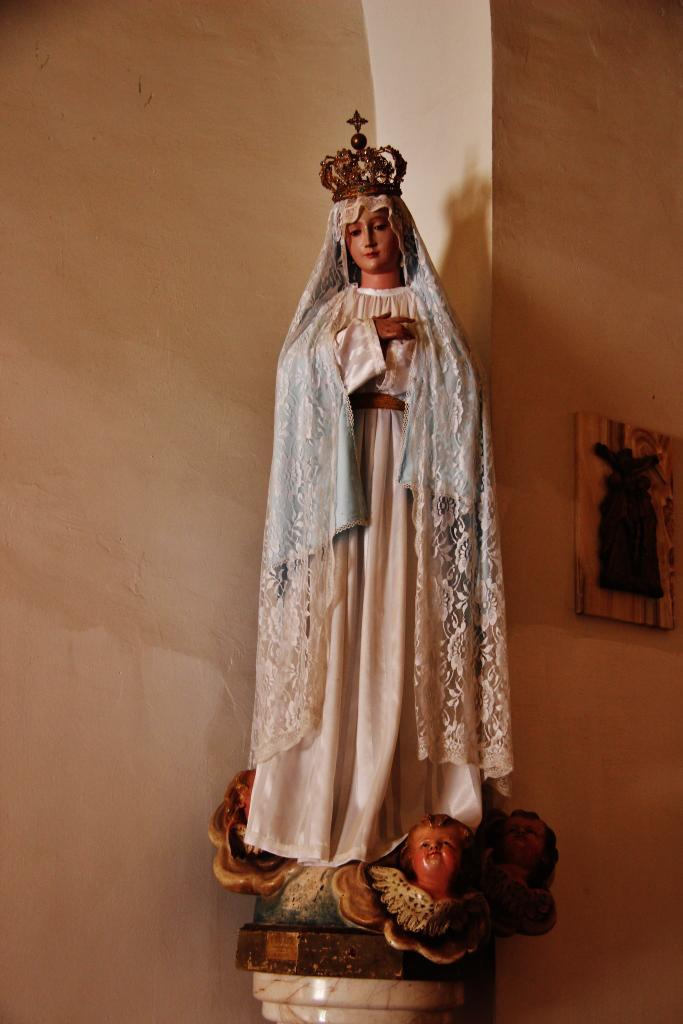What is the main subject in the foreground of the image? There is a statue in the foreground of the image. What can be seen on the wall in the background of the image? There is a frame-like object on the wall in the background of the image. Is there a pocket on the statue in the image? No, there is no pocket on the statue in the image. 